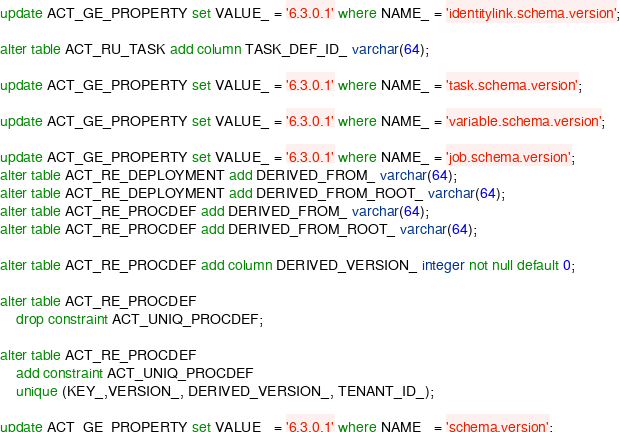<code> <loc_0><loc_0><loc_500><loc_500><_SQL_>update ACT_GE_PROPERTY set VALUE_ = '6.3.0.1' where NAME_ = 'identitylink.schema.version';

alter table ACT_RU_TASK add column TASK_DEF_ID_ varchar(64);

update ACT_GE_PROPERTY set VALUE_ = '6.3.0.1' where NAME_ = 'task.schema.version';

update ACT_GE_PROPERTY set VALUE_ = '6.3.0.1' where NAME_ = 'variable.schema.version';

update ACT_GE_PROPERTY set VALUE_ = '6.3.0.1' where NAME_ = 'job.schema.version';
alter table ACT_RE_DEPLOYMENT add DERIVED_FROM_ varchar(64);
alter table ACT_RE_DEPLOYMENT add DERIVED_FROM_ROOT_ varchar(64);
alter table ACT_RE_PROCDEF add DERIVED_FROM_ varchar(64);
alter table ACT_RE_PROCDEF add DERIVED_FROM_ROOT_ varchar(64);

alter table ACT_RE_PROCDEF add column DERIVED_VERSION_ integer not null default 0;

alter table ACT_RE_PROCDEF
    drop constraint ACT_UNIQ_PROCDEF;
    
alter table ACT_RE_PROCDEF
    add constraint ACT_UNIQ_PROCDEF
    unique (KEY_,VERSION_, DERIVED_VERSION_, TENANT_ID_);

update ACT_GE_PROPERTY set VALUE_ = '6.3.0.1' where NAME_ = 'schema.version';

</code> 